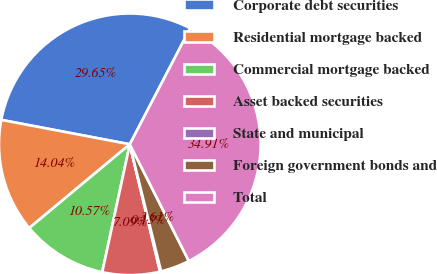Convert chart. <chart><loc_0><loc_0><loc_500><loc_500><pie_chart><fcel>Corporate debt securities<fcel>Residential mortgage backed<fcel>Commercial mortgage backed<fcel>Asset backed securities<fcel>State and municipal<fcel>Foreign government bonds and<fcel>Total<nl><fcel>29.65%<fcel>14.04%<fcel>10.57%<fcel>7.09%<fcel>0.13%<fcel>3.61%<fcel>34.91%<nl></chart> 